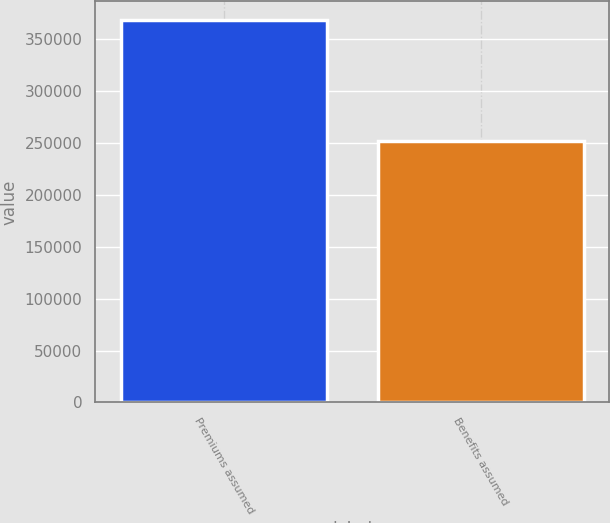<chart> <loc_0><loc_0><loc_500><loc_500><bar_chart><fcel>Premiums assumed<fcel>Benefits assumed<nl><fcel>368138<fcel>252159<nl></chart> 